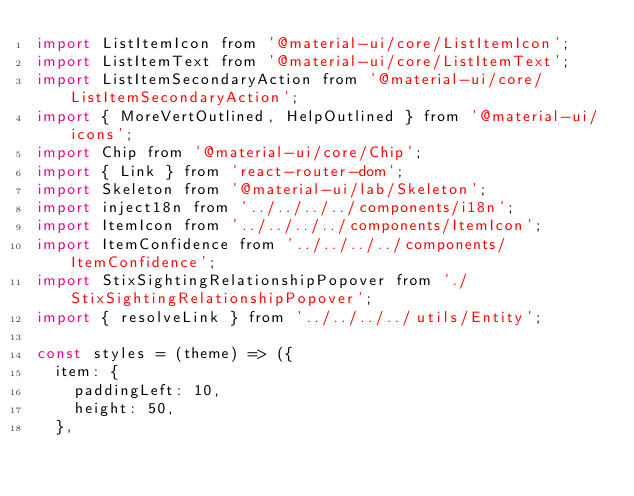Convert code to text. <code><loc_0><loc_0><loc_500><loc_500><_JavaScript_>import ListItemIcon from '@material-ui/core/ListItemIcon';
import ListItemText from '@material-ui/core/ListItemText';
import ListItemSecondaryAction from '@material-ui/core/ListItemSecondaryAction';
import { MoreVertOutlined, HelpOutlined } from '@material-ui/icons';
import Chip from '@material-ui/core/Chip';
import { Link } from 'react-router-dom';
import Skeleton from '@material-ui/lab/Skeleton';
import inject18n from '../../../../components/i18n';
import ItemIcon from '../../../../components/ItemIcon';
import ItemConfidence from '../../../../components/ItemConfidence';
import StixSightingRelationshipPopover from './StixSightingRelationshipPopover';
import { resolveLink } from '../../../../utils/Entity';

const styles = (theme) => ({
  item: {
    paddingLeft: 10,
    height: 50,
  },</code> 